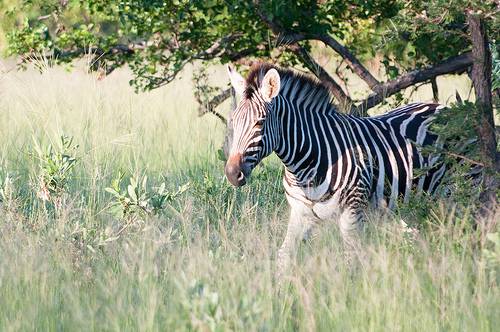Describe the mood of the image. The mood of the image is serene and tranquil. The zebra appears calm and at ease in its natural habitat, surrounded by gently swaying tall grass and the verdant backdrop of trees. The warm, natural lighting adds to the peaceful ambiance, making the scene feel calm and harmonious. If this were part of a story, what would you title it? "Graceful Wanderer: A Day in the Savannah" Write an extremely detailed and creative story based on the image. In the heart of the sprawling African savannah, where the golden rays of dawn flirted with the dewdrops on the blades of tall grass, a lone zebra named Zuri began her day. The gentle murmur of the wind whispered through the trees, carrying the sweet chorus of morning birds. As the sunlight filtered through the dense canopy, it cast a mystical dappled pattern on Zuri's striking black and white stripes, an artwork of nature's own making.

Zuri stepped lightly, her hooves barely disturbing the earth beneath her. Her ears twitched, picking up the distant calls of her herd. But today, Zuri felt an insatiable curiosity pulling her away from the group, leading her deeper into an enclave of towering acacias and lush undergrowth.

The savannah was abuzz with life. A dazzle of colorful butterflies fluttered around blooming wildflowers, while a family of meerkats stood sentinel on a mound nearby, their eyes scanning for both food and threats. Behind the veil of the dense foliage, the soft, rhythmic rush of a hidden stream called to Zuri, promising fresh water and adventure.

As she approached the stream, Zuri noticed a kaleidoscope of colors play on its surface, reflecting the iridescence of the sky above. She bent down to drink, savoring the cool, crystal-clear water. Her eyes caught sight of a pair of sleek, golden eyes observing her from the underbrush. It was a young cheetah, curious but not yet ready for the hunt.

They shared a moment of mutual respect, recognizing each other's presence but not perceiving one another as immediate threats. As if in an unspoken truce, the two creatures coexisted harmoniously in the shared space, before each turned back to their respective paths. Zuri, now refreshed, began her walk back to her herd with a newfound perspective on the intricate balance of life that surrounded her.

The sun climbed higher, casting a warm glow across the landscape. Birds of various hues flitted from branch to branch, casting fleeting shadows on the ground. The leaves rustled in a gentle breeze—a natural symphony that seemed to accompany Zuri’s every step. And as she neared her family once more, she carried with her the secrets and stories of the savannah, woven into her being like the stripes that adorned her. What might be a potential threat to the zebra in this environment? A potential threat to the zebra in this environment could be predators such as lions, cheetahs, or hyenas. These carnivorous animals are natural hunters and often target zebras for their strength and agility, requiring the zebra to stay vigilant for its survival. Why might a zebra's stripes be beneficial in this habitat? A zebra's stripes are beneficial in this habitat as they provide camouflage by breaking up the outline of the zebra's body. This makes it difficult for predators to single out an individual from the herd, especially in the dappled light of wooded areas or tall grass. Additionally, stripes may help in social bonding and recognition among zebras, as well as potentially repelling biting insects. 